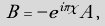Convert formula to latex. <formula><loc_0><loc_0><loc_500><loc_500>B = - e ^ { i \pi \chi } A ,</formula> 